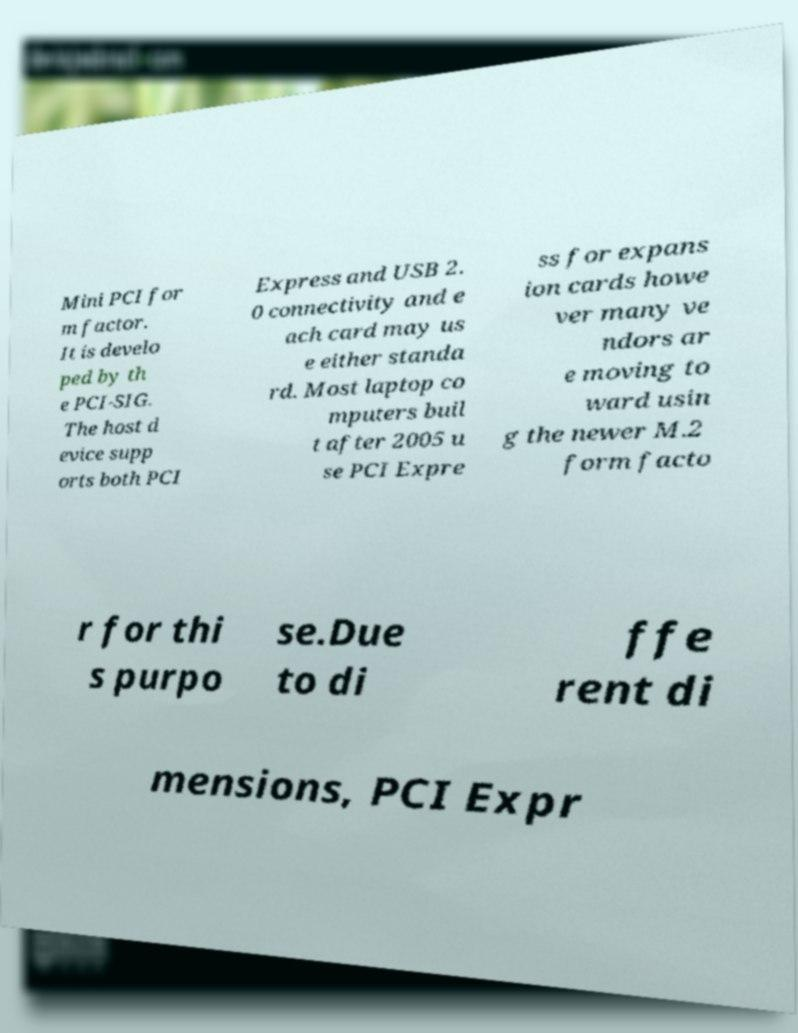Could you assist in decoding the text presented in this image and type it out clearly? Mini PCI for m factor. It is develo ped by th e PCI-SIG. The host d evice supp orts both PCI Express and USB 2. 0 connectivity and e ach card may us e either standa rd. Most laptop co mputers buil t after 2005 u se PCI Expre ss for expans ion cards howe ver many ve ndors ar e moving to ward usin g the newer M.2 form facto r for thi s purpo se.Due to di ffe rent di mensions, PCI Expr 